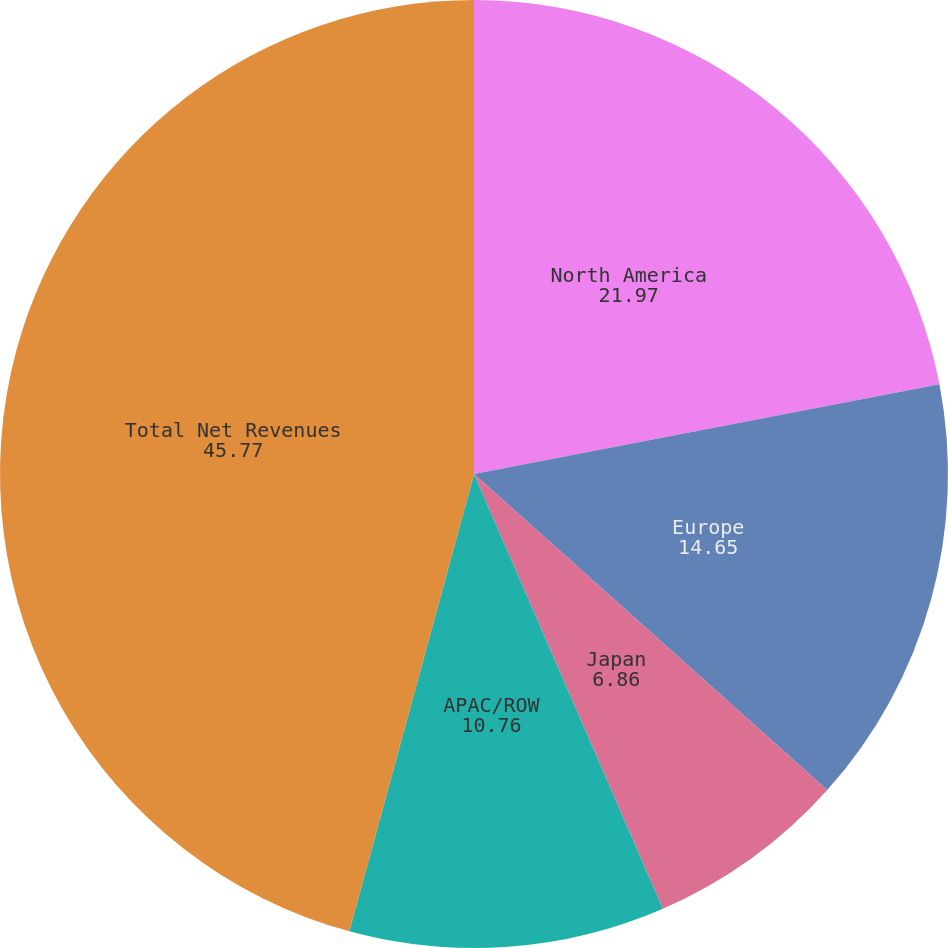Convert chart to OTSL. <chart><loc_0><loc_0><loc_500><loc_500><pie_chart><fcel>North America<fcel>Europe<fcel>Japan<fcel>APAC/ROW<fcel>Total Net Revenues<nl><fcel>21.97%<fcel>14.65%<fcel>6.86%<fcel>10.76%<fcel>45.77%<nl></chart> 